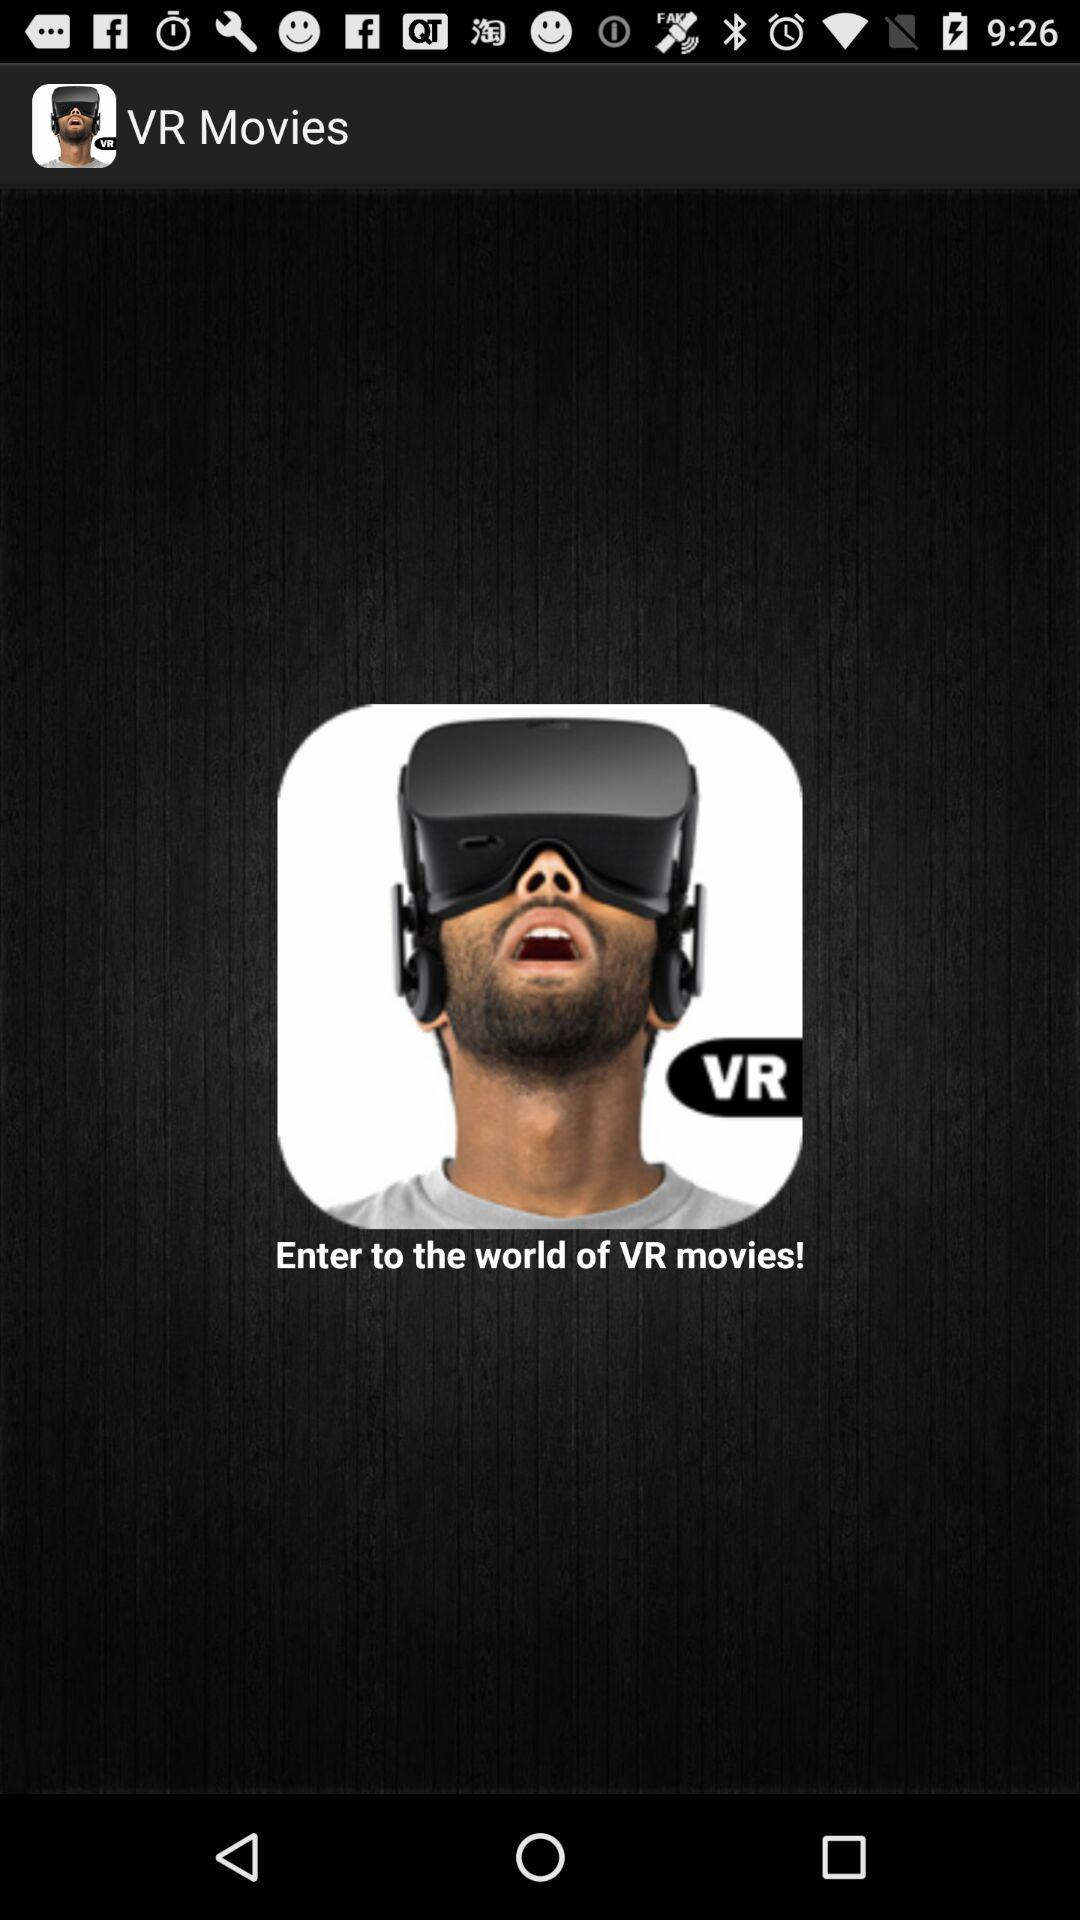What is the application name? The application name is "VR Movies". 